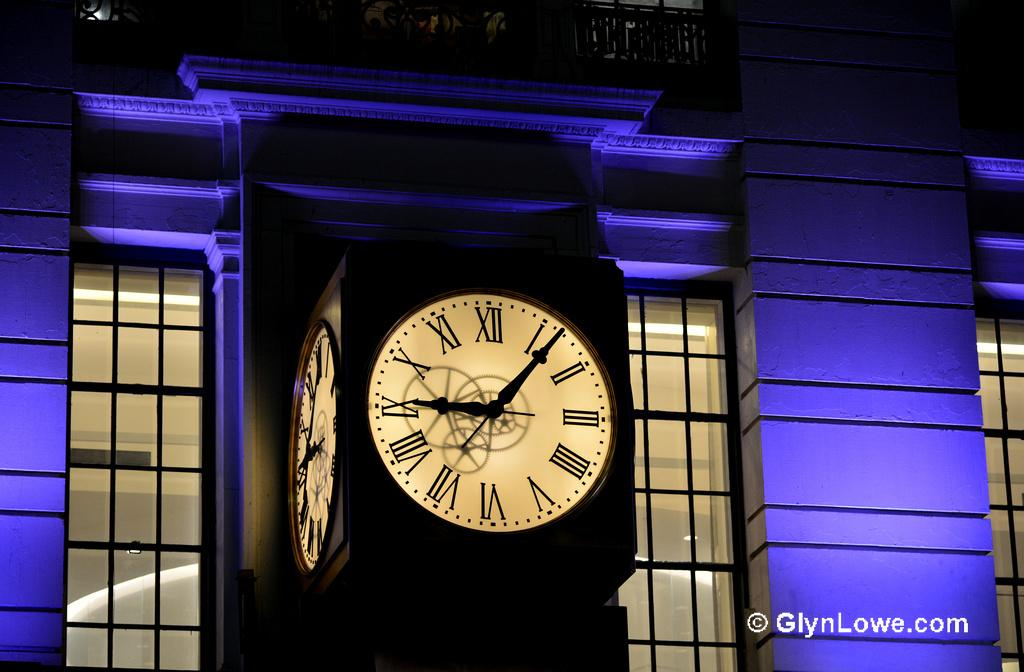<image>
Provide a brief description of the given image. A clock at night that is lit up with the time reading 9:06. 